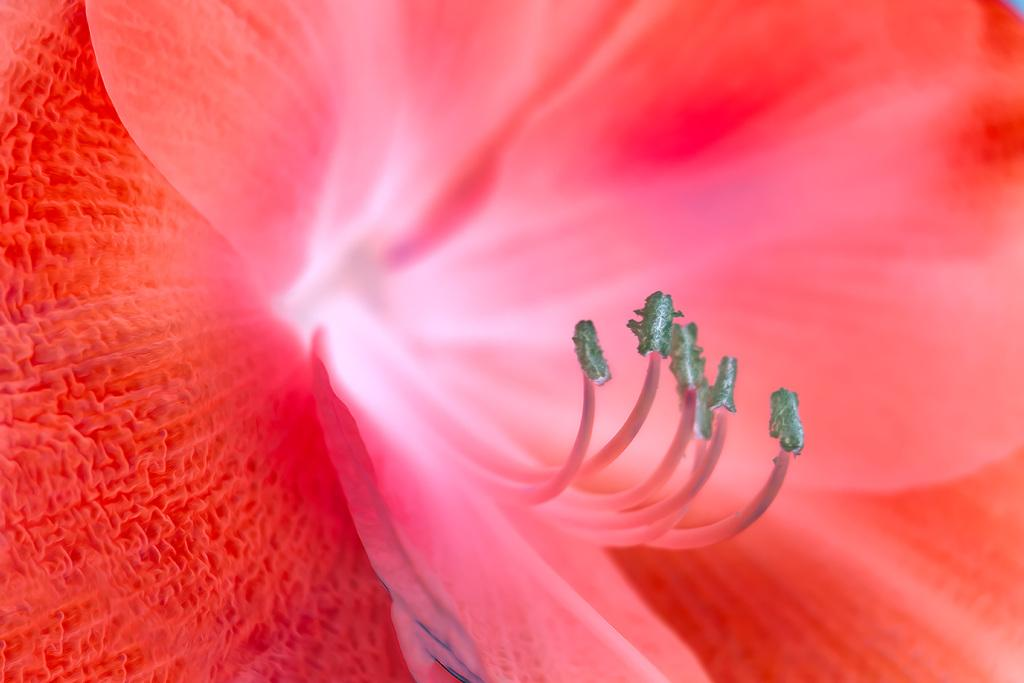What is the main subject of the zoomed-in picture? The subject of the image is a flower. What specific parts of the flower can be seen in the image? The petals of the flower are visible in the image. Are there any other parts of the flower visible in the image? Some parts of the flower are visible in the image. How many kittens can be seen playing with the goose in the image? There are no kittens or goose present in the image; it features a flower. Can you describe how the flower moves in the image? The flower does not move in the image; it is stationary. 